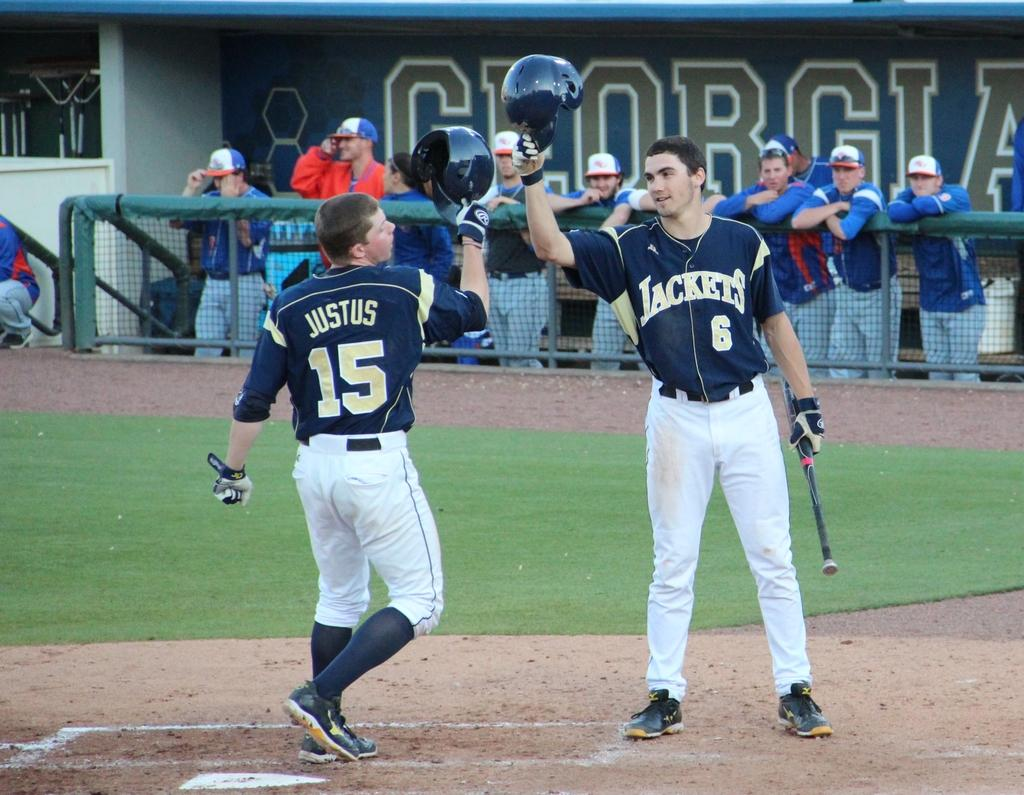<image>
Relay a brief, clear account of the picture shown. Two Jackets baseball players raise their helmets to one another on field. 